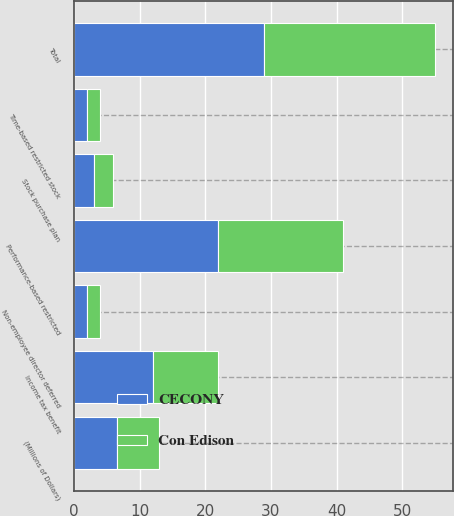Convert chart. <chart><loc_0><loc_0><loc_500><loc_500><stacked_bar_chart><ecel><fcel>(Millions of Dollars)<fcel>Performance-based restricted<fcel>Time-based restricted stock<fcel>Non-employee director deferred<fcel>Stock purchase plan<fcel>Total<fcel>Income tax benefit<nl><fcel>CECONY<fcel>6.5<fcel>22<fcel>2<fcel>2<fcel>3<fcel>29<fcel>12<nl><fcel>Con Edison<fcel>6.5<fcel>19<fcel>2<fcel>2<fcel>3<fcel>26<fcel>10<nl></chart> 